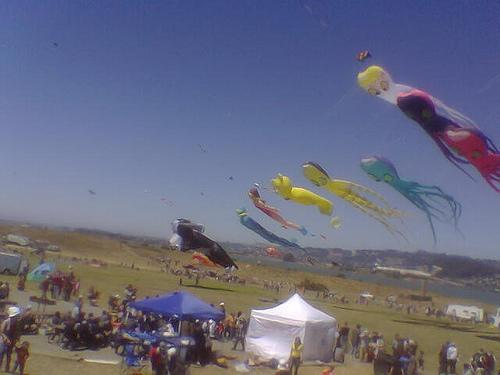What type of structures are shown? tents 